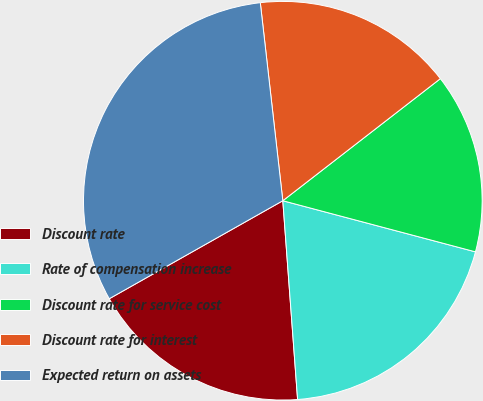Convert chart to OTSL. <chart><loc_0><loc_0><loc_500><loc_500><pie_chart><fcel>Discount rate<fcel>Rate of compensation increase<fcel>Discount rate for service cost<fcel>Discount rate for interest<fcel>Expected return on assets<nl><fcel>18.0%<fcel>19.69%<fcel>14.62%<fcel>16.31%<fcel>31.38%<nl></chart> 